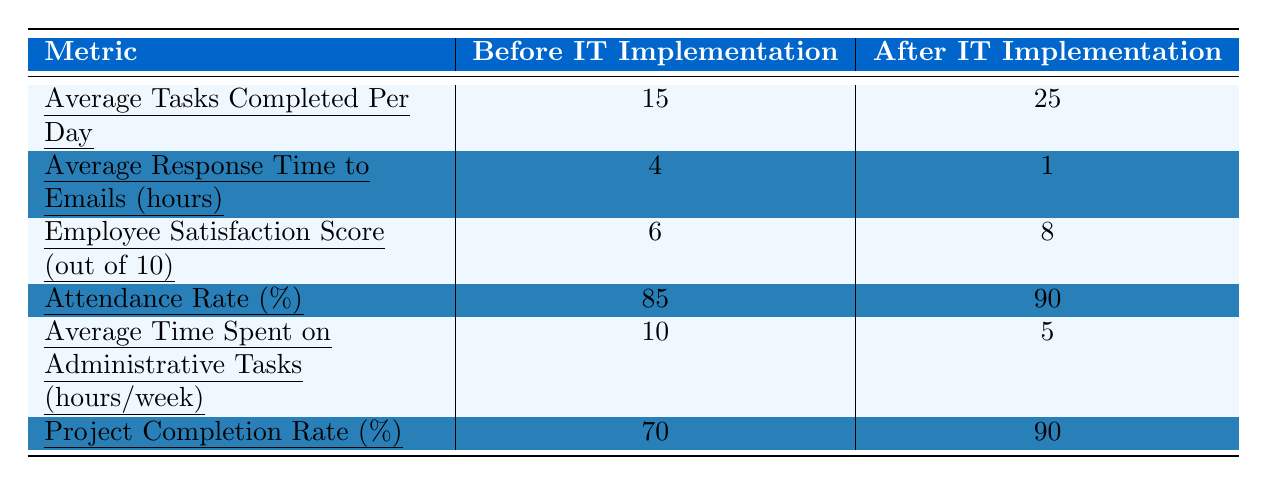What was the average number of tasks completed per day before the IT implementation? The table shows that the average tasks completed per day before IT implementation is 15.
Answer: 15 What is the employee satisfaction score after the IT implementation? According to the table, the employee satisfaction score after the IT implementation is 8 out of 10.
Answer: 8 How many more tasks are completed per day after the IT implementation compared to before? The difference in tasks completed per day is 25 (after) - 15 (before) = 10.
Answer: 10 What was the average response time to emails before the IT implementation? The table indicates that the average response time to emails before the IT implementation was 4 hours.
Answer: 4 hours Is the attendance rate higher after the IT implementation compared to before? Yes, the attendance rate increased from 85% before to 90% after the IT implementation.
Answer: Yes What is the percentage increase in the project completion rate after IT implementation? The increase in project completion rate is calculated as (90% - 70%) / 70% * 100 = 28.57%.
Answer: 28.57% How much time was saved in administrative tasks on average per week after IT implementation? The average time spent on administrative tasks decreased from 10 hours to 5 hours, saving 5 hours per week.
Answer: 5 hours Which metric showed the largest improvement after IT implementation? The most significant improvement can be seen in the average tasks completed per day, which increased from 15 to 25, a difference of 10.
Answer: Average tasks completed per day What are the average values of employee satisfaction scores before and after IT implementation? Before IT implementation, the score was 6, and after it was 8. Thus, the average values are 6 and 8 respectively.
Answer: 6 and 8 Did the average time spent on administrative tasks increase or decrease after IT implementation? The average time spent on administrative tasks decreased from 10 hours per week to 5 hours per week after implementation.
Answer: Decrease 